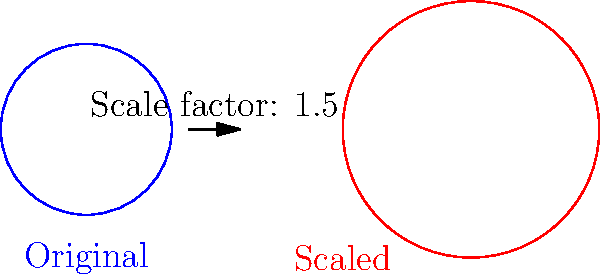Your company's circular logo has a diameter of 2 inches. For a new billboard campaign, you need to scale up the logo so that its area is 2.25 times larger than the original. What is the scale factor you should apply to the logo's dimensions? Let's approach this step-by-step:

1) First, recall that when we scale a two-dimensional figure, its area changes by the square of the scale factor. If we denote the scale factor as $s$, then:

   $\text{New Area} = s^2 \times \text{Original Area}$

2) We're told that the new area should be 2.25 times the original area. So we can write:

   $2.25 = s^2$

3) To find $s$, we need to take the square root of both sides:

   $s = \sqrt{2.25}$

4) Simplify:
   
   $s = 1.5$

5) This means we need to multiply both the width and height of the logo by 1.5 to achieve an area that is 2.25 times larger.

6) We can verify: $1.5^2 = 2.25$, which confirms our result.

Therefore, to scale the logo so its area is 2.25 times larger, you should apply a scale factor of 1.5 to the logo's dimensions.
Answer: 1.5 